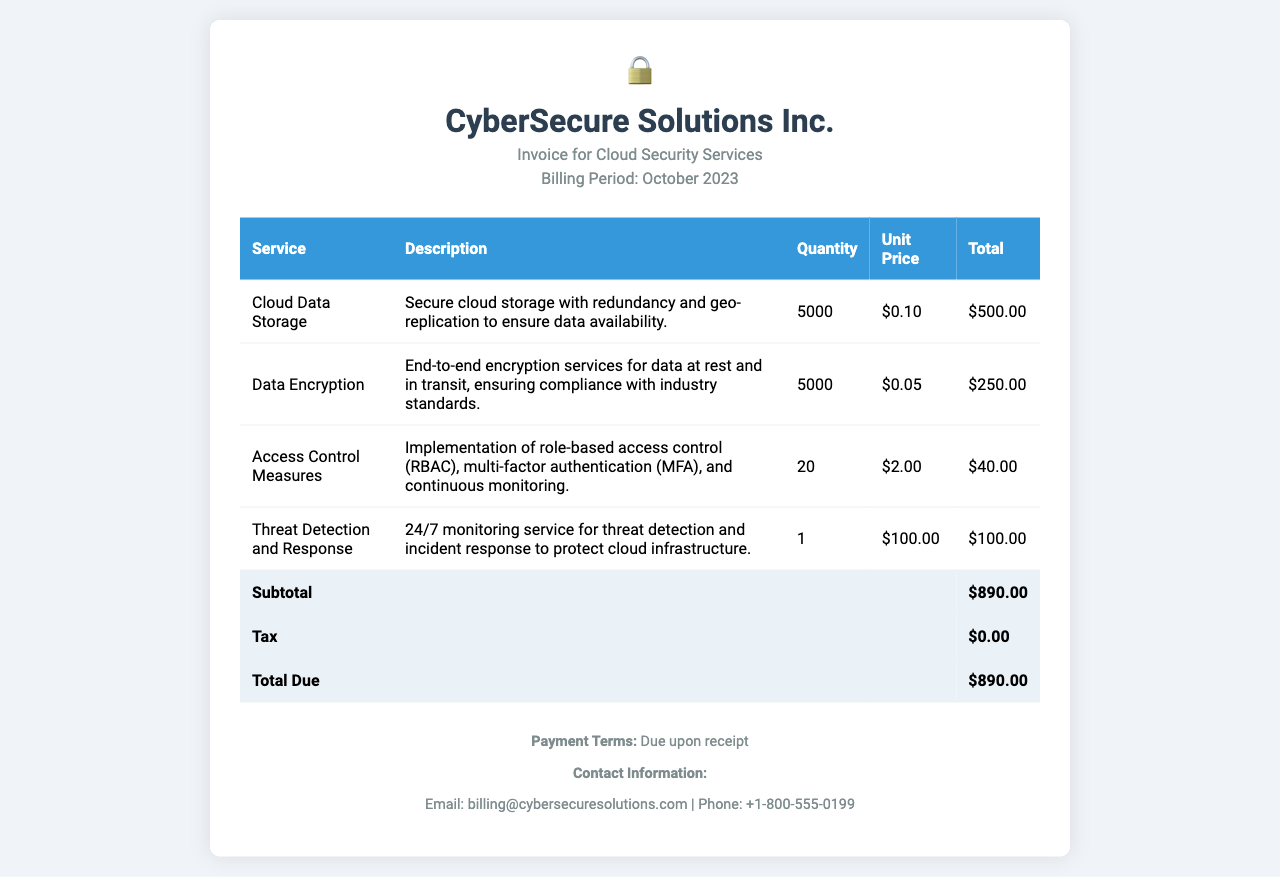What is the billing period? The billing period is specified in the document header as October 2023.
Answer: October 2023 How much is the total due for the services? The total due is clearly mentioned in the invoice summary.
Answer: $890.00 What is the unit price for Data Encryption? The unit price for Data Encryption is given in the table.
Answer: $0.05 How many units of Access Control Measures were billed? The quantity is specified in the corresponding row of the table.
Answer: 20 What is included in the description for Cloud Data Storage? The description mentions secure cloud storage with redundancy and geo-replication.
Answer: Secure cloud storage with redundancy and geo-replication What type of access control measures were implemented? The document outlines specific types of access control measures in the description section.
Answer: Role-based access control (RBAC), multi-factor authentication (MFA), and continuous monitoring What is the subtotal before tax? The subtotal is explicitly listed in the total row of the invoice.
Answer: $890.00 Is there any tax charged on the services? The tax section in the invoice clearly indicates the amount for tax.
Answer: $0.00 What is the contact email for billing inquiries? The contact email is provided in the footer of the invoice.
Answer: billing@cybersecuresolutions.com 